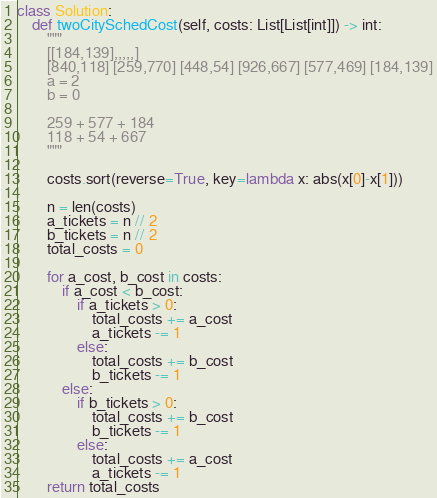<code> <loc_0><loc_0><loc_500><loc_500><_Python_>class Solution:
    def twoCitySchedCost(self, costs: List[List[int]]) -> int:
        """
        [[184,139],,,,,]
        [840,118] [259,770] [448,54] [926,667] [577,469] [184,139]
        a = 2
        b = 0
        
        259 + 577 + 184
        118 + 54 + 667
        """
        
        costs.sort(reverse=True, key=lambda x: abs(x[0]-x[1]))
        
        n = len(costs)
        a_tickets = n // 2
        b_tickets = n // 2
        total_costs = 0
        
        for a_cost, b_cost in costs:
            if a_cost < b_cost:
                if a_tickets > 0:
                    total_costs += a_cost
                    a_tickets -= 1
                else:
                    total_costs += b_cost
                    b_tickets -= 1
            else:
                if b_tickets > 0:
                    total_costs += b_cost
                    b_tickets -= 1
                else:
                    total_costs += a_cost
                    a_tickets -= 1
        return total_costs</code> 